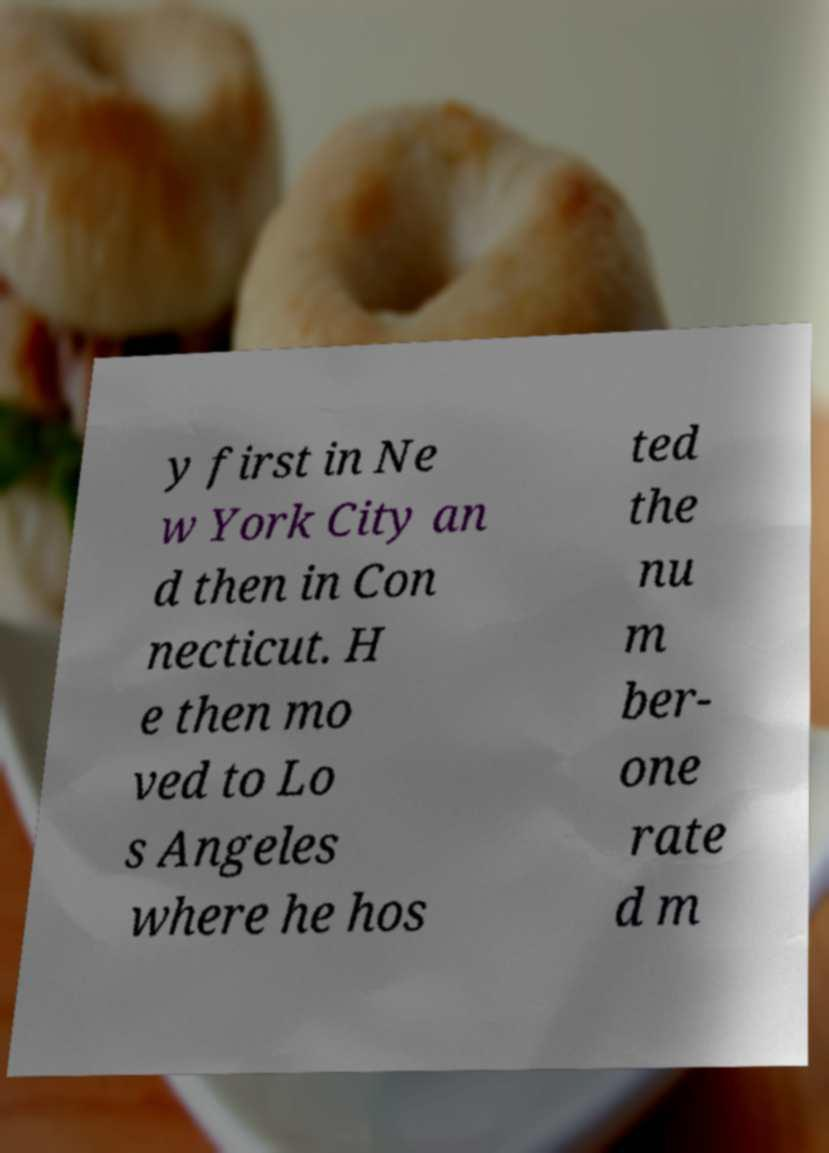Could you extract and type out the text from this image? y first in Ne w York City an d then in Con necticut. H e then mo ved to Lo s Angeles where he hos ted the nu m ber- one rate d m 